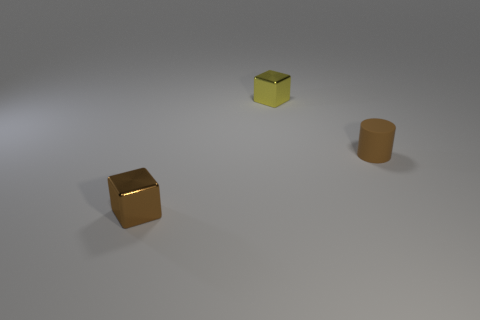Add 1 rubber cylinders. How many objects exist? 4 Subtract all yellow blocks. How many blocks are left? 1 Subtract 1 blocks. How many blocks are left? 1 Subtract all cylinders. How many objects are left? 2 Subtract all blue cubes. Subtract all purple cylinders. How many cubes are left? 2 Subtract all tiny brown matte cylinders. Subtract all large red balls. How many objects are left? 2 Add 3 tiny things. How many tiny things are left? 6 Add 3 brown objects. How many brown objects exist? 5 Subtract 0 purple cylinders. How many objects are left? 3 